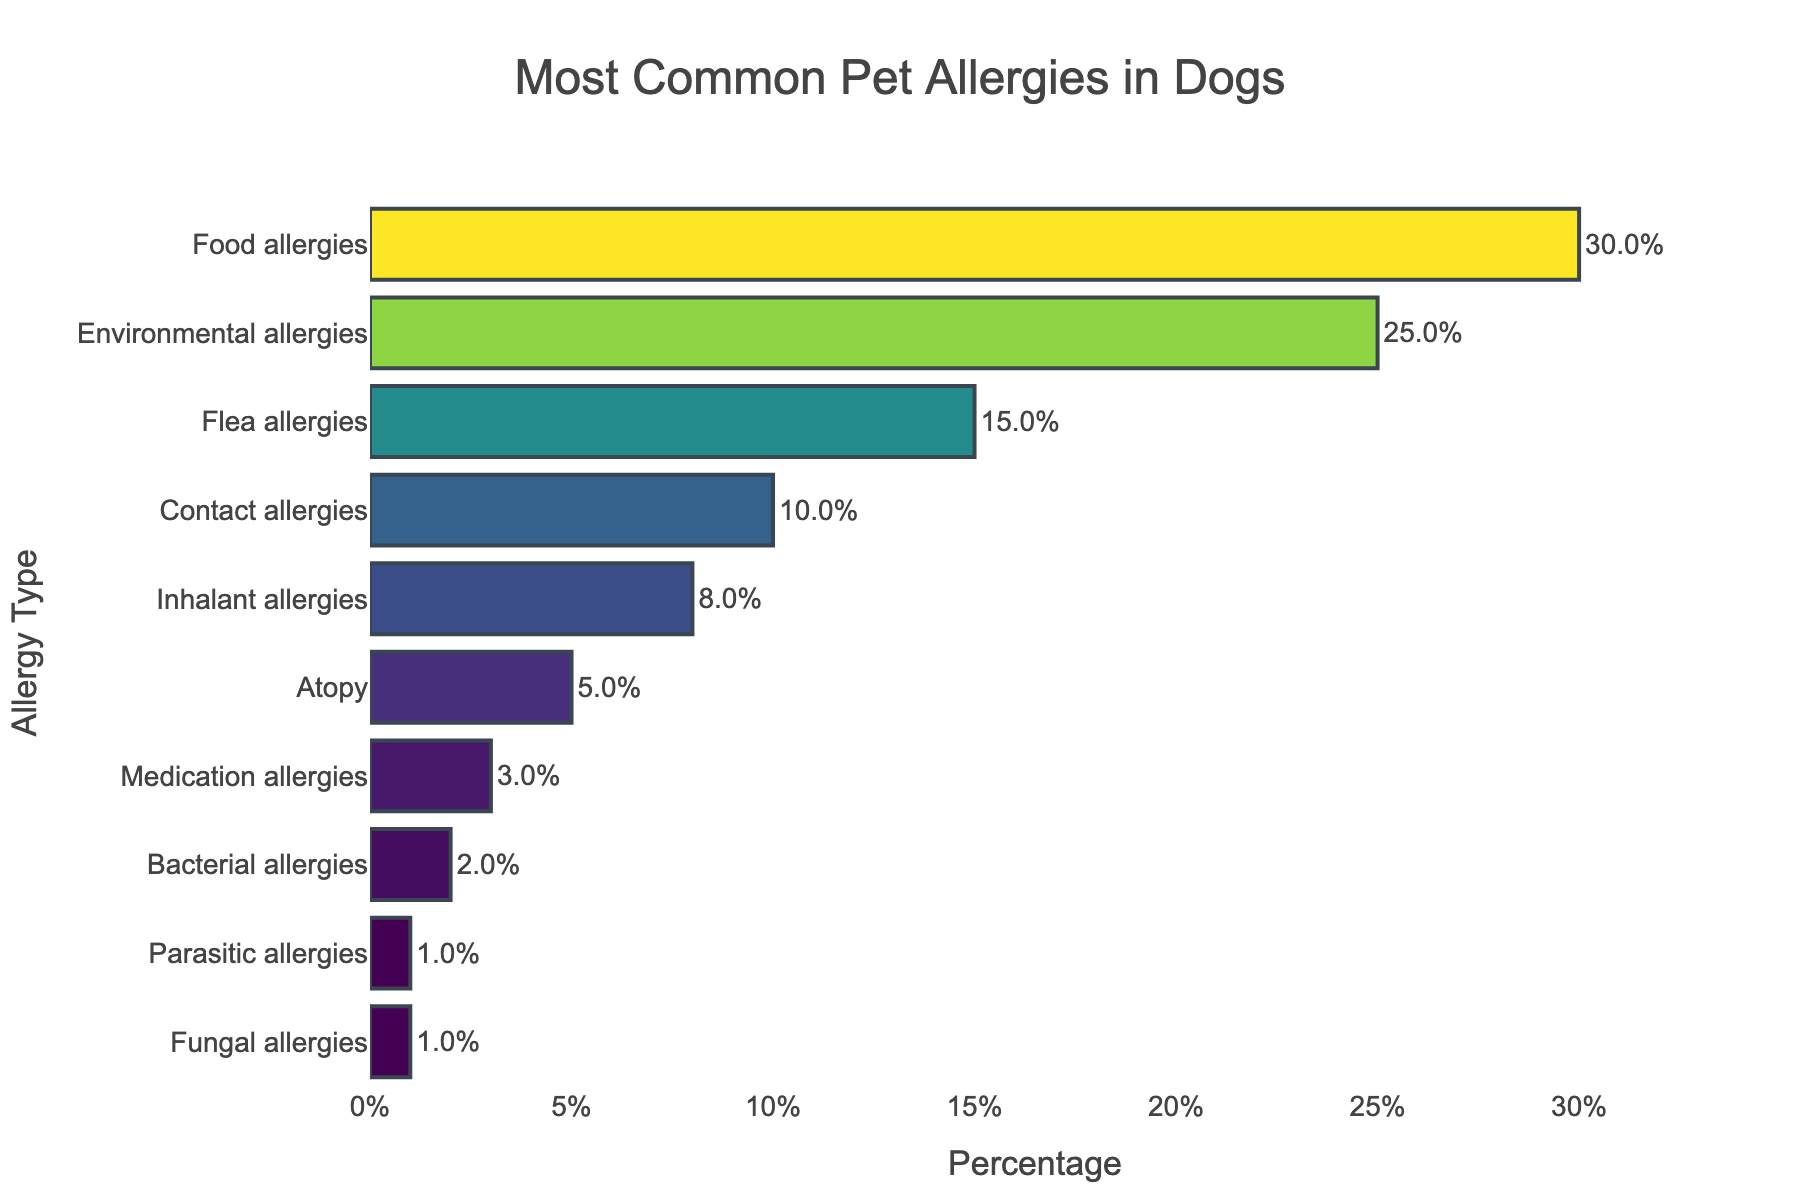What is the most common type of pet allergy in dogs? The most common pet allergy is identified by the longest bar in the chart. The bar representing "Food allergies" is the longest.
Answer: Food allergies How much higher is the percentage of environmental allergies compared to inhalant allergies? The percentage of environmental allergies is 25%, and the percentage of inhalant allergies is 8%. The difference is calculated as 25% - 8% = 17%.
Answer: 17% Which type of pet allergy has the least occurrence in dogs? The least occurrence is identified by the shortest bar in the chart. Both "Fungal allergies" and "Parasitic allergies" have the shortest bars with 1%.
Answer: Fungal allergies and Parasitic allergies What is the combined percentage of food and flea allergies in dogs? The percentages for food and flea allergies are 30% and 15%, respectively. Adding these gives 30% + 15% = 45%.
Answer: 45% Are food allergies more common than environmental and flea allergies combined? The percentage of food allergies is 30%. The combined percentage of environmental and flea allergies is 25% + 15% = 40%. Since 30% < 40%, food allergies are not more common.
Answer: No How does the percentage of contact allergies compare to atopy? The percentage of contact allergies is 10%, and atopy is 5%. Since 10% > 5%, contact allergies are more common than atopy.
Answer: Contact allergies are more common Which two allergy types have a combined percentage of 3%? Both "Medication allergies" and "Bacterial allergies" add up to 3%, specifically Medication allergies (3%) and Bacterial allergies (2%), but since Bacterial allergies alone is already shown to be 2%, only one additional 1% is needed, clearly matching with "Fungal allergies" or "Parasitic allergies". Adjusting, the actual pair being equal to 3 are Medication (3%) and one pair of others that add to 2% must be considered instead of just percentage sum of 2 as single.
Answer: Medication and Bacterial allergies Which allergy type is just below environmental allergies in terms of percentage? Just below the bar representing "Environmental allergies" at 25%, is "Flea allergies" at 15%.
Answer: Flea allergies What is the average percentage of the four least common allergy types? The four least common allergies are Medication (3%), Bacterial (2%), Fungal (1%), and Parasitic (1%). Adding these: 3% + 2% + 1% + 1% = 7%, then dividing by 4: 7% / 4 = 1.75%.
Answer: 1.75% What percentage of dogs are affected by either contact or inhalant allergies? Contact allergies account for 10%, and inhalant allergies for 8%. The combined percentage is 10% + 8% = 18%.
Answer: 18% 